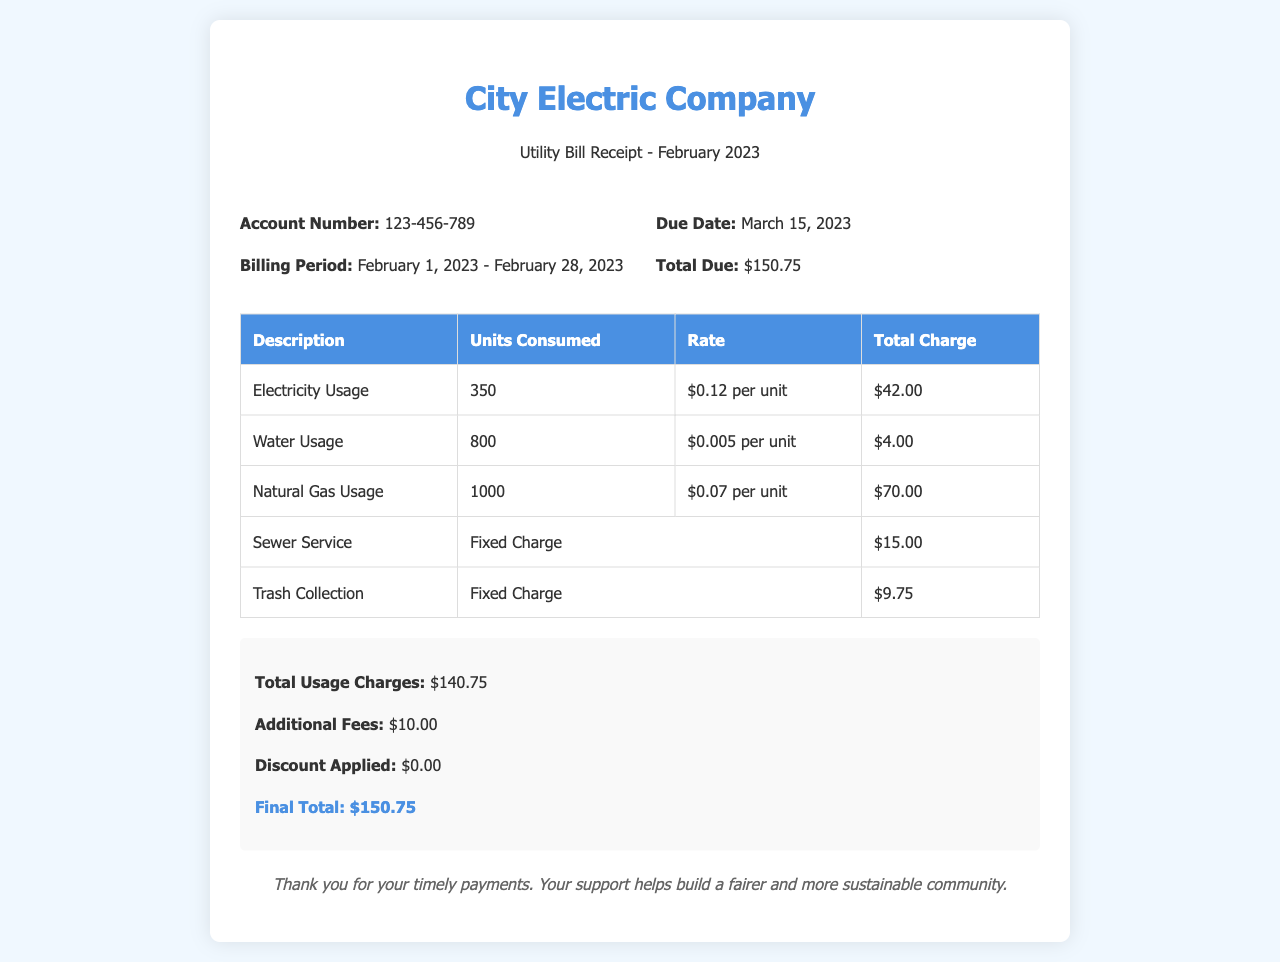What is the account number? The account number is specified in the document, which is 123-456-789.
Answer: 123-456-789 What is the billing period? The billing period is clearly mentioned as February 1, 2023 - February 28, 2023.
Answer: February 1, 2023 - February 28, 2023 What is the total due amount? The total due amount is stated in the document as $150.75.
Answer: $150.75 How many units of electricity were consumed? The document provides the electricity consumption as 350 units.
Answer: 350 What is the rate per unit for water usage? The rate for water usage is provided in the document as $0.005 per unit.
Answer: $0.005 per unit What is the total charge for natural gas usage? The document indicates that the total charge for natural gas usage is $70.00.
Answer: $70.00 What are additional fees? Additional fees are listed in the document, which amounts to $10.00.
Answer: $10.00 What is the final total amount due? The final total amount is calculated and stated as $150.75 in the document.
Answer: $150.75 What fixed charge is applicable for sewer service? The document indicates that the fixed charge for sewer service is $15.00.
Answer: $15.00 